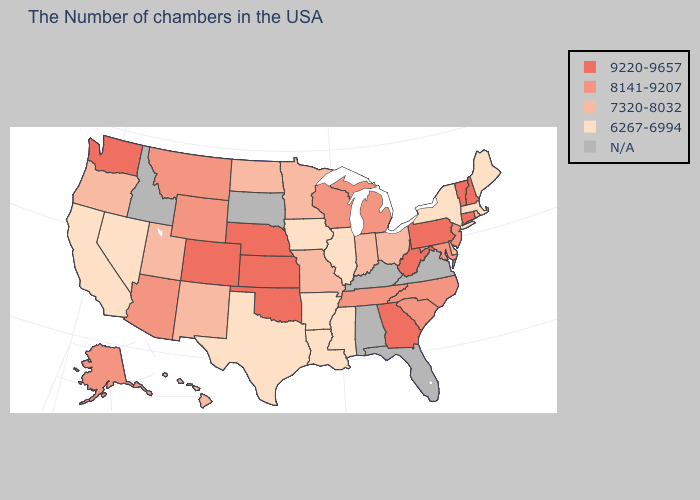What is the lowest value in states that border Arizona?
Give a very brief answer. 6267-6994. Which states hav the highest value in the Northeast?
Concise answer only. New Hampshire, Vermont, Connecticut, Pennsylvania. Is the legend a continuous bar?
Short answer required. No. What is the value of Florida?
Quick response, please. N/A. Name the states that have a value in the range N/A?
Be succinct. Virginia, Florida, Kentucky, Alabama, South Dakota, Idaho. Name the states that have a value in the range 9220-9657?
Short answer required. New Hampshire, Vermont, Connecticut, Pennsylvania, West Virginia, Georgia, Kansas, Nebraska, Oklahoma, Colorado, Washington. What is the value of California?
Give a very brief answer. 6267-6994. What is the highest value in the USA?
Write a very short answer. 9220-9657. What is the highest value in the USA?
Short answer required. 9220-9657. What is the highest value in states that border Nevada?
Answer briefly. 8141-9207. Name the states that have a value in the range 8141-9207?
Be succinct. New Jersey, Maryland, North Carolina, South Carolina, Michigan, Tennessee, Wisconsin, Wyoming, Montana, Arizona, Alaska. What is the value of Kansas?
Quick response, please. 9220-9657. Which states hav the highest value in the MidWest?
Be succinct. Kansas, Nebraska. Which states have the lowest value in the USA?
Write a very short answer. Maine, Massachusetts, New York, Illinois, Mississippi, Louisiana, Arkansas, Iowa, Texas, Nevada, California. Name the states that have a value in the range 7320-8032?
Quick response, please. Rhode Island, Delaware, Ohio, Indiana, Missouri, Minnesota, North Dakota, New Mexico, Utah, Oregon, Hawaii. 